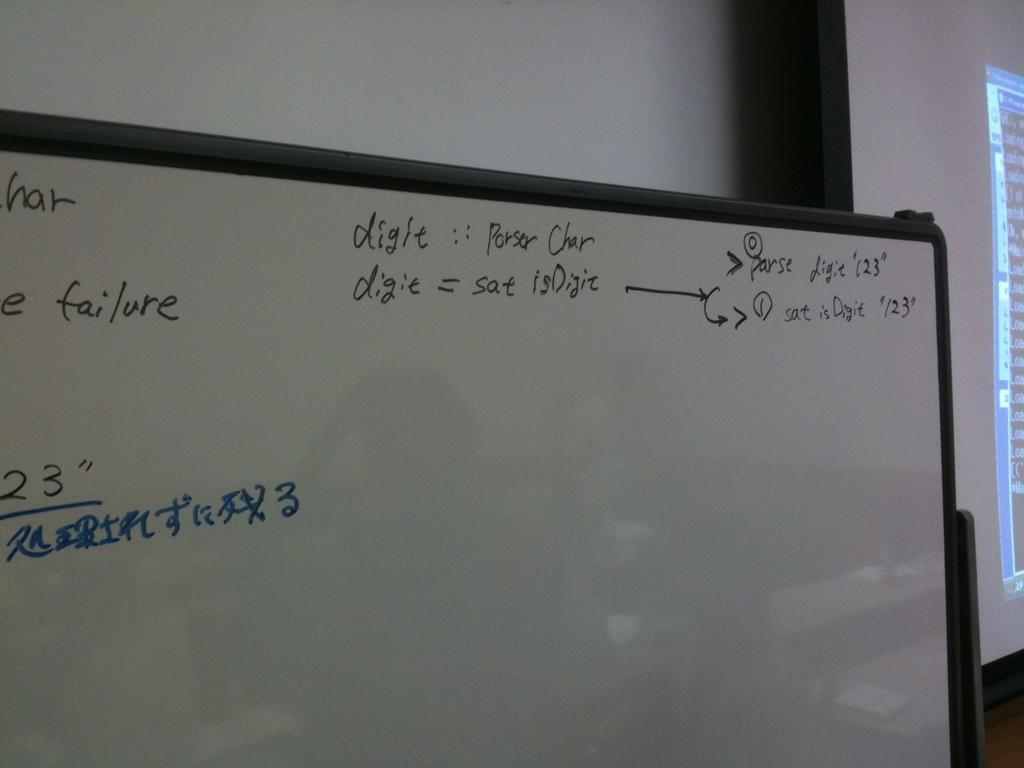<image>
Render a clear and concise summary of the photo. A white board with words like digie and failure written on it 